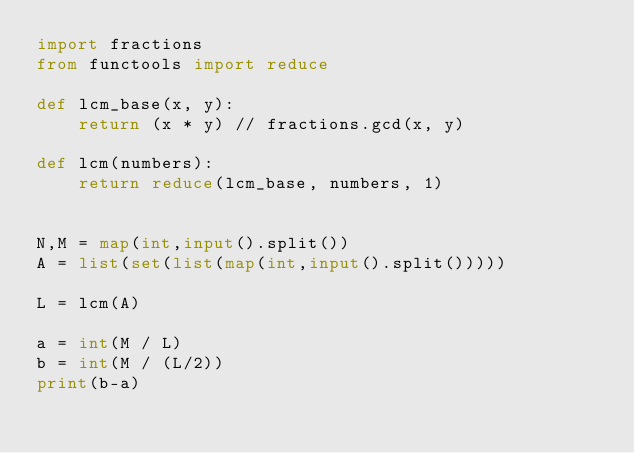<code> <loc_0><loc_0><loc_500><loc_500><_Python_>import fractions
from functools import reduce

def lcm_base(x, y):
    return (x * y) // fractions.gcd(x, y)

def lcm(numbers):
    return reduce(lcm_base, numbers, 1)


N,M = map(int,input().split())
A = list(set(list(map(int,input().split()))))

L = lcm(A)

a = int(M / L)
b = int(M / (L/2))
print(b-a)
</code> 